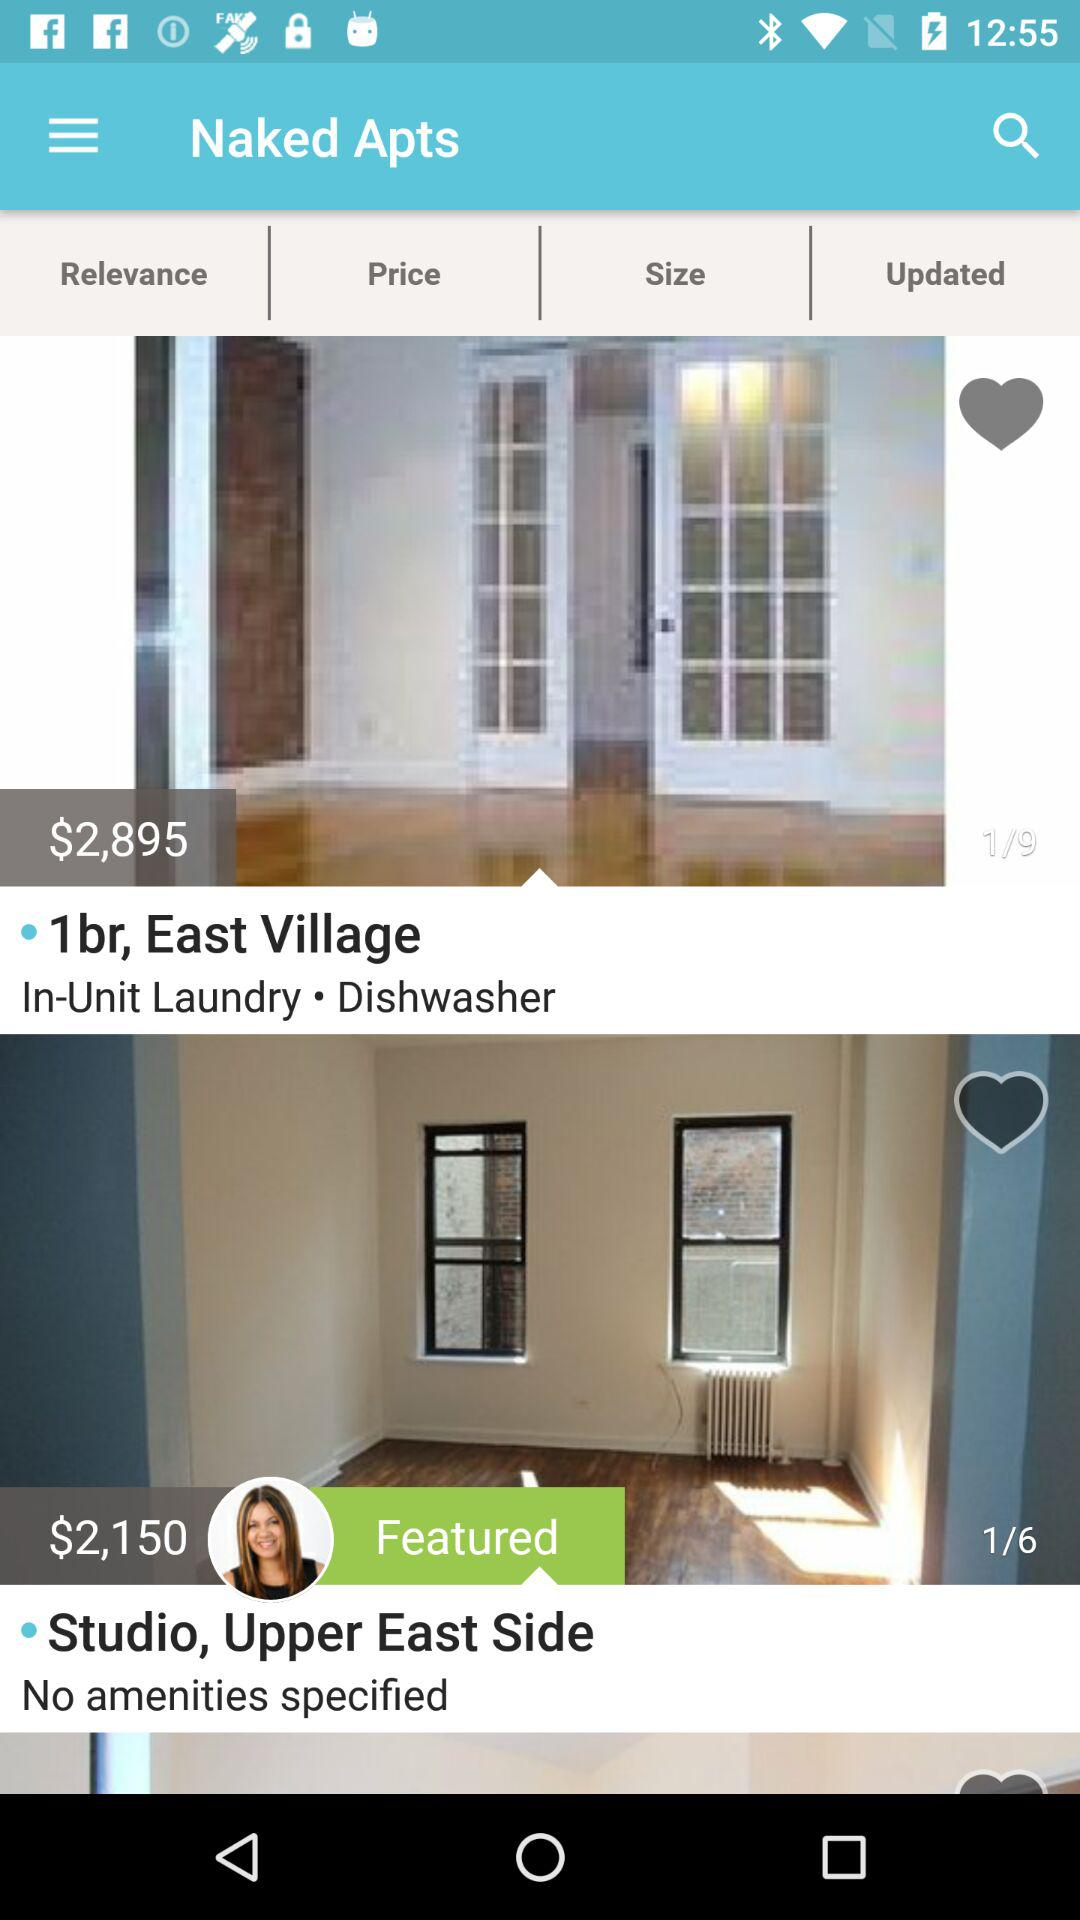What amenities are given for the 1-bedroom apartment in the East Village? The amenities that are given for the 1-bedroom apartment in the East Village are "In-Unit Laundry" and "Dishwasher". 